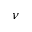<formula> <loc_0><loc_0><loc_500><loc_500>\nu</formula> 